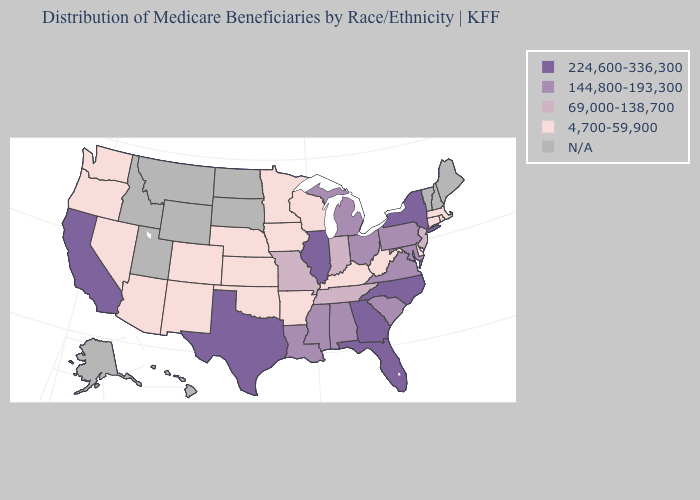Which states have the lowest value in the West?
Concise answer only. Arizona, Colorado, Nevada, New Mexico, Oregon, Washington. Which states hav the highest value in the West?
Be succinct. California. Which states have the lowest value in the USA?
Keep it brief. Arizona, Arkansas, Colorado, Connecticut, Delaware, Iowa, Kansas, Kentucky, Massachusetts, Minnesota, Nebraska, Nevada, New Mexico, Oklahoma, Oregon, Rhode Island, Washington, West Virginia, Wisconsin. What is the value of Maine?
Concise answer only. N/A. Does the map have missing data?
Concise answer only. Yes. Among the states that border Louisiana , which have the lowest value?
Give a very brief answer. Arkansas. Which states have the lowest value in the USA?
Be succinct. Arizona, Arkansas, Colorado, Connecticut, Delaware, Iowa, Kansas, Kentucky, Massachusetts, Minnesota, Nebraska, Nevada, New Mexico, Oklahoma, Oregon, Rhode Island, Washington, West Virginia, Wisconsin. Which states have the highest value in the USA?
Quick response, please. California, Florida, Georgia, Illinois, New York, North Carolina, Texas. What is the highest value in the USA?
Write a very short answer. 224,600-336,300. Name the states that have a value in the range 69,000-138,700?
Answer briefly. Indiana, Missouri, New Jersey, Tennessee. What is the value of Arkansas?
Short answer required. 4,700-59,900. Name the states that have a value in the range 224,600-336,300?
Answer briefly. California, Florida, Georgia, Illinois, New York, North Carolina, Texas. Name the states that have a value in the range 144,800-193,300?
Answer briefly. Alabama, Louisiana, Maryland, Michigan, Mississippi, Ohio, Pennsylvania, South Carolina, Virginia. Which states hav the highest value in the West?
Keep it brief. California. Does Maryland have the highest value in the South?
Give a very brief answer. No. 